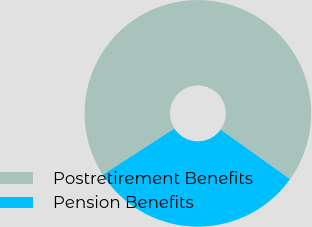Convert chart to OTSL. <chart><loc_0><loc_0><loc_500><loc_500><pie_chart><fcel>Postretirement Benefits<fcel>Pension Benefits<nl><fcel>69.0%<fcel>31.0%<nl></chart> 